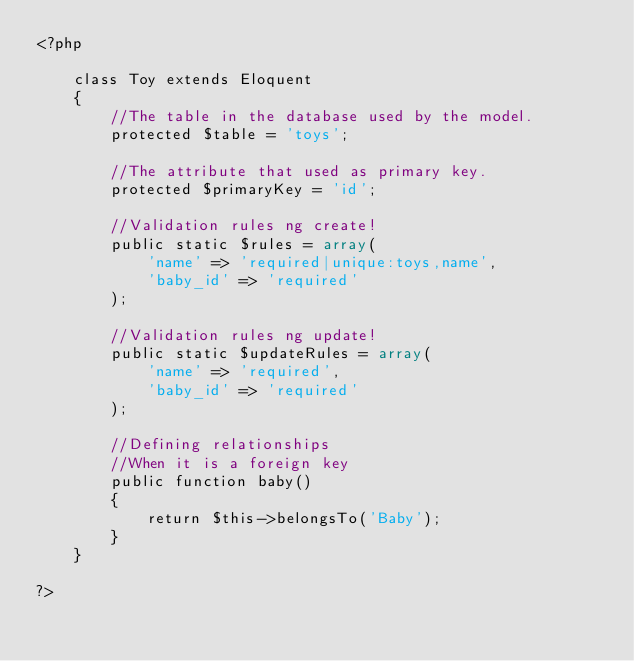<code> <loc_0><loc_0><loc_500><loc_500><_PHP_><?php

	class Toy extends Eloquent 
	{
		//The table in the database used by the model.
		protected $table = 'toys';

		//The attribute that used as primary key.
		protected $primaryKey = 'id';

		//Validation rules ng create!
		public static $rules = array(
			'name' => 'required|unique:toys,name',
			'baby_id' => 'required'
		);

		//Validation rules ng update!
		public static $updateRules = array(
			'name' => 'required',
			'baby_id' => 'required'
		);

		//Defining relationships
		//When it is a foreign key
		public function baby()
		{
			return $this->belongsTo('Baby');
		}
	}

?></code> 